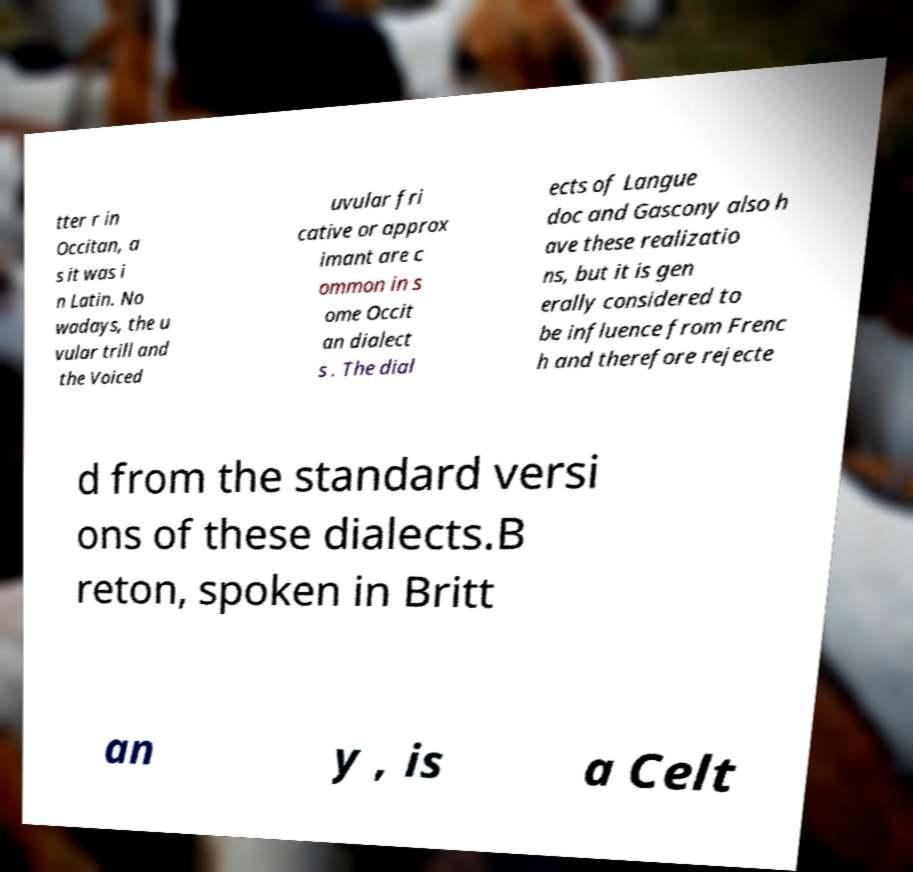There's text embedded in this image that I need extracted. Can you transcribe it verbatim? tter r in Occitan, a s it was i n Latin. No wadays, the u vular trill and the Voiced uvular fri cative or approx imant are c ommon in s ome Occit an dialect s . The dial ects of Langue doc and Gascony also h ave these realizatio ns, but it is gen erally considered to be influence from Frenc h and therefore rejecte d from the standard versi ons of these dialects.B reton, spoken in Britt an y , is a Celt 